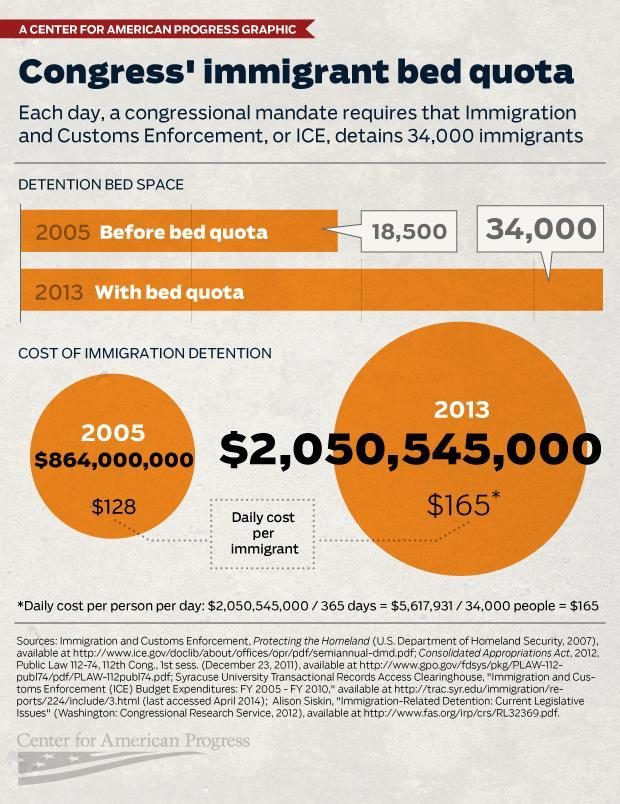What was the cost of immigration detention for the year 2013?
Answer the question with a short phrase. $2,050,545,000 In which year was the cost per immigrant per day equal to $128? 2005 What was the cost of immigration detention for the year 2005? $864,000,000 In which year was the cost per immigrant per day equal to $165? 2013 How many immigrants could be detained each day in 2005? 18,500 